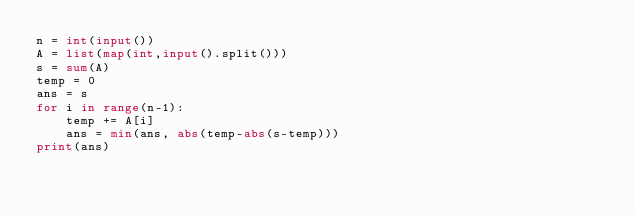Convert code to text. <code><loc_0><loc_0><loc_500><loc_500><_Python_>n = int(input())
A = list(map(int,input().split()))
s = sum(A)
temp = 0
ans = s
for i in range(n-1):
    temp += A[i]
    ans = min(ans, abs(temp-abs(s-temp)))
print(ans)
</code> 